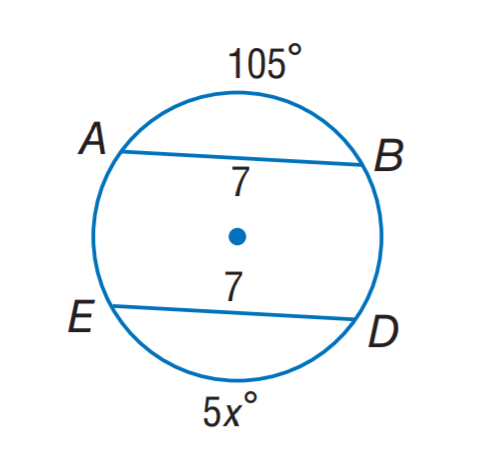Answer the mathemtical geometry problem and directly provide the correct option letter.
Question: Find x.
Choices: A: 7 B: 15 C: 21 D: 75 C 